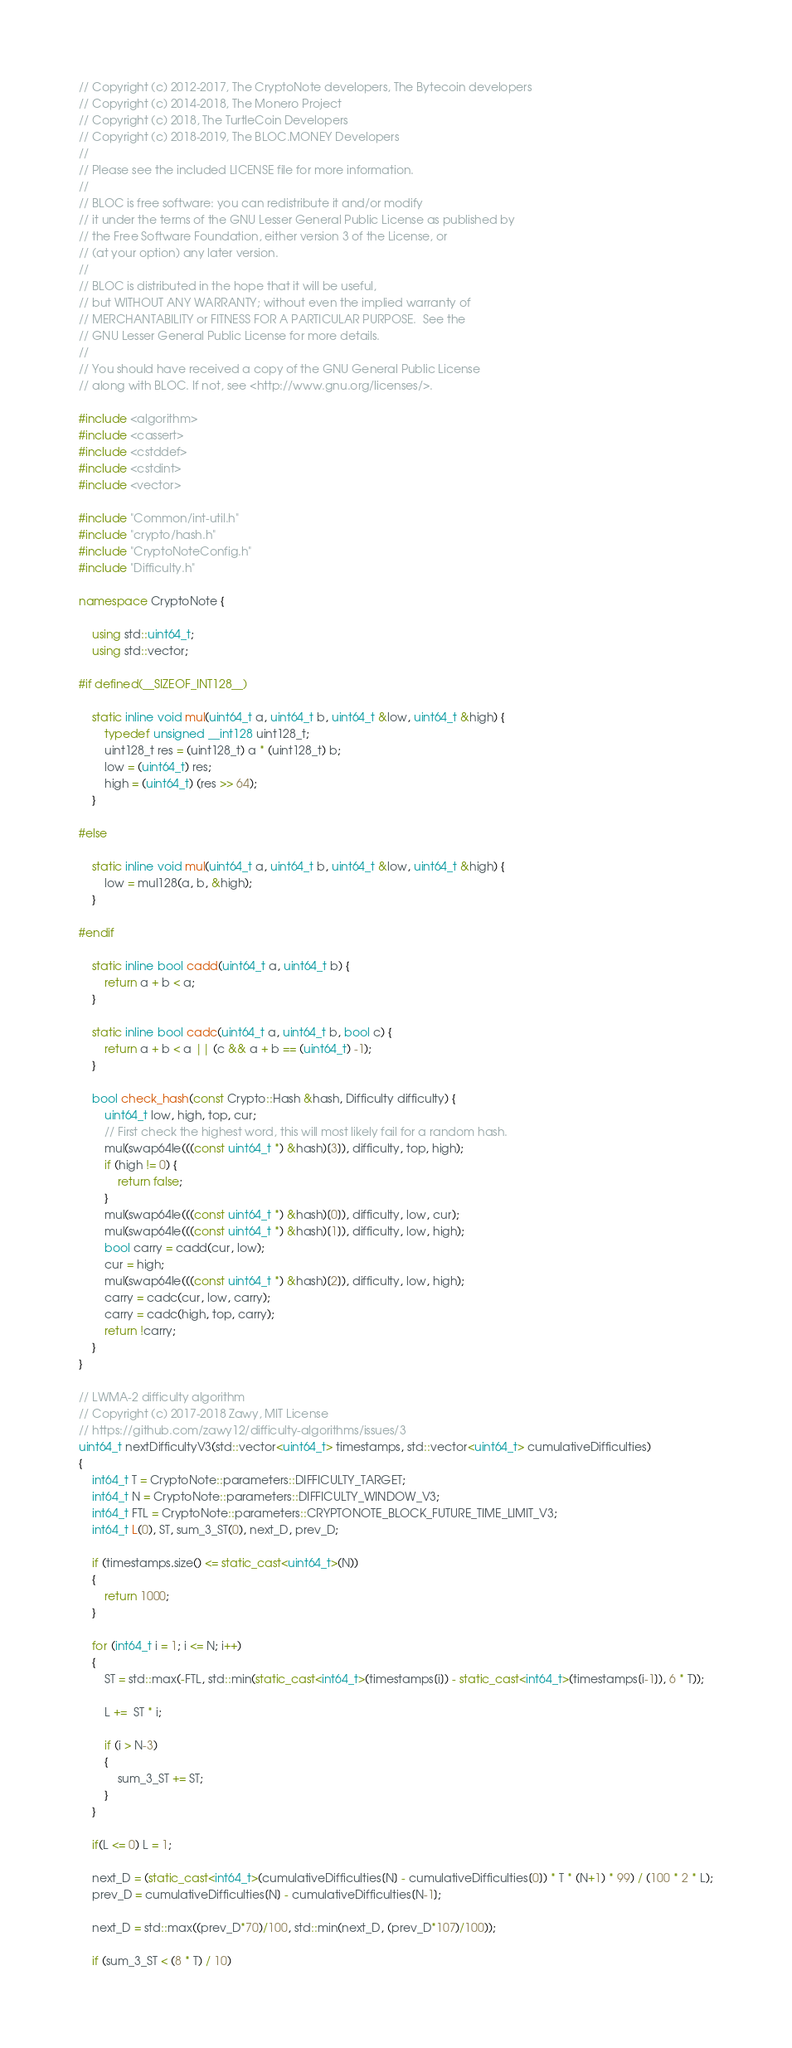<code> <loc_0><loc_0><loc_500><loc_500><_C++_>// Copyright (c) 2012-2017, The CryptoNote developers, The Bytecoin developers
// Copyright (c) 2014-2018, The Monero Project
// Copyright (c) 2018, The TurtleCoin Developers
// Copyright (c) 2018-2019, The BLOC.MONEY Developers
//
// Please see the included LICENSE file for more information.
// 
// BLOC is free software: you can redistribute it and/or modify
// it under the terms of the GNU Lesser General Public License as published by
// the Free Software Foundation, either version 3 of the License, or
// (at your option) any later version.
// 
// BLOC is distributed in the hope that it will be useful,
// but WITHOUT ANY WARRANTY; without even the implied warranty of
// MERCHANTABILITY or FITNESS FOR A PARTICULAR PURPOSE.  See the
// GNU Lesser General Public License for more details.
// 
// You should have received a copy of the GNU General Public License
// along with BLOC. If not, see <http://www.gnu.org/licenses/>.

#include <algorithm>
#include <cassert>
#include <cstddef>
#include <cstdint>
#include <vector>

#include "Common/int-util.h"
#include "crypto/hash.h"
#include "CryptoNoteConfig.h"
#include "Difficulty.h"

namespace CryptoNote {
    
    using std::uint64_t;
    using std::vector;
    
#if defined(__SIZEOF_INT128__)
    
    static inline void mul(uint64_t a, uint64_t b, uint64_t &low, uint64_t &high) {
        typedef unsigned __int128 uint128_t;
        uint128_t res = (uint128_t) a * (uint128_t) b;
        low = (uint64_t) res;
        high = (uint64_t) (res >> 64);
    }
    
#else
    
    static inline void mul(uint64_t a, uint64_t b, uint64_t &low, uint64_t &high) {
        low = mul128(a, b, &high);
    }
    
#endif
    
    static inline bool cadd(uint64_t a, uint64_t b) {
        return a + b < a;
    }
    
    static inline bool cadc(uint64_t a, uint64_t b, bool c) {
        return a + b < a || (c && a + b == (uint64_t) -1);
    }
    
    bool check_hash(const Crypto::Hash &hash, Difficulty difficulty) {
        uint64_t low, high, top, cur;
        // First check the highest word, this will most likely fail for a random hash.
        mul(swap64le(((const uint64_t *) &hash)[3]), difficulty, top, high);
        if (high != 0) {
            return false;
        }
        mul(swap64le(((const uint64_t *) &hash)[0]), difficulty, low, cur);
        mul(swap64le(((const uint64_t *) &hash)[1]), difficulty, low, high);
        bool carry = cadd(cur, low);
        cur = high;
        mul(swap64le(((const uint64_t *) &hash)[2]), difficulty, low, high);
        carry = cadc(cur, low, carry);
        carry = cadc(high, top, carry);
        return !carry;
    }
}

// LWMA-2 difficulty algorithm
// Copyright (c) 2017-2018 Zawy, MIT License
// https://github.com/zawy12/difficulty-algorithms/issues/3
uint64_t nextDifficultyV3(std::vector<uint64_t> timestamps, std::vector<uint64_t> cumulativeDifficulties)
{
    int64_t T = CryptoNote::parameters::DIFFICULTY_TARGET;
    int64_t N = CryptoNote::parameters::DIFFICULTY_WINDOW_V3;
    int64_t FTL = CryptoNote::parameters::CRYPTONOTE_BLOCK_FUTURE_TIME_LIMIT_V3;
    int64_t L(0), ST, sum_3_ST(0), next_D, prev_D;
    
    if (timestamps.size() <= static_cast<uint64_t>(N))
    {
        return 1000;
    }
    
    for (int64_t i = 1; i <= N; i++)
    {
        ST = std::max(-FTL, std::min(static_cast<int64_t>(timestamps[i]) - static_cast<int64_t>(timestamps[i-1]), 6 * T));
        
        L +=  ST * i;
        
        if (i > N-3)
        {
            sum_3_ST += ST;
        }
    }
    
    if(L <= 0) L = 1;
    
    next_D = (static_cast<int64_t>(cumulativeDifficulties[N] - cumulativeDifficulties[0]) * T * (N+1) * 99) / (100 * 2 * L);
    prev_D = cumulativeDifficulties[N] - cumulativeDifficulties[N-1];
    
    next_D = std::max((prev_D*70)/100, std::min(next_D, (prev_D*107)/100));
    
    if (sum_3_ST < (8 * T) / 10)</code> 